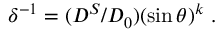Convert formula to latex. <formula><loc_0><loc_0><loc_500><loc_500>\delta ^ { - 1 } = ( D ^ { S } / D _ { 0 } ) ( \sin \theta ) ^ { k } \ .</formula> 